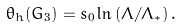Convert formula to latex. <formula><loc_0><loc_0><loc_500><loc_500>\theta _ { h } ( G _ { 3 } ) = s _ { 0 } \ln \left ( \Lambda / \Lambda _ { * } \right ) .</formula> 